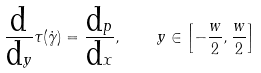<formula> <loc_0><loc_0><loc_500><loc_500>\frac { \text {d} } { \text {d} y } \tau ( \dot { \gamma } ) = \frac { \text {d} p } { \text {d} x } , \quad y \in \left [ - \frac { w } { 2 } , \frac { w } { 2 } \right ]</formula> 